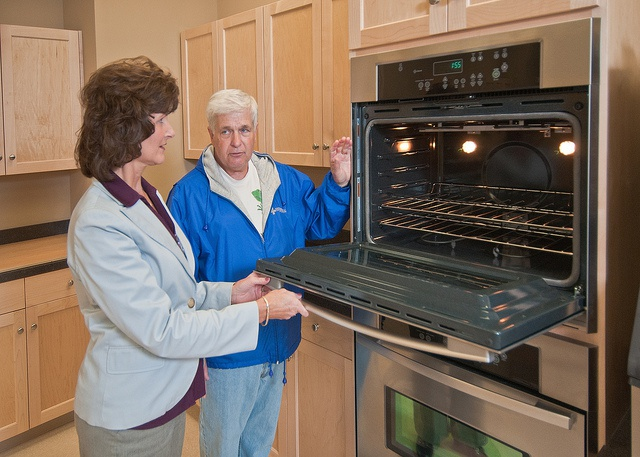Describe the objects in this image and their specific colors. I can see oven in gray and black tones, people in gray, darkgray, and lightgray tones, people in gray, blue, and darkgray tones, and oven in gray, black, and darkgreen tones in this image. 